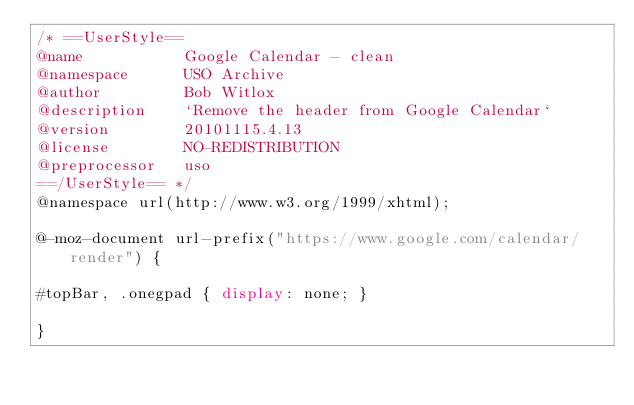<code> <loc_0><loc_0><loc_500><loc_500><_CSS_>/* ==UserStyle==
@name           Google Calendar - clean
@namespace      USO Archive
@author         Bob Witlox
@description    `Remove the header from Google Calendar`
@version        20101115.4.13
@license        NO-REDISTRIBUTION
@preprocessor   uso
==/UserStyle== */
@namespace url(http://www.w3.org/1999/xhtml);

@-moz-document url-prefix("https://www.google.com/calendar/render") {

#topBar, .onegpad { display: none; }

}</code> 